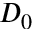<formula> <loc_0><loc_0><loc_500><loc_500>D _ { 0 }</formula> 